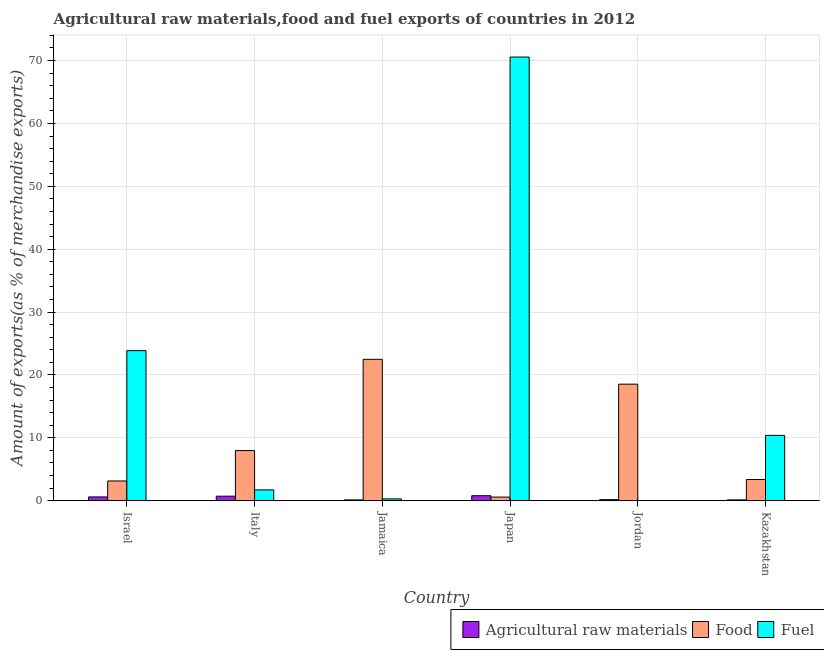How many groups of bars are there?
Provide a succinct answer. 6. Are the number of bars on each tick of the X-axis equal?
Keep it short and to the point. Yes. How many bars are there on the 3rd tick from the left?
Give a very brief answer. 3. How many bars are there on the 2nd tick from the right?
Your answer should be very brief. 3. What is the label of the 5th group of bars from the left?
Your answer should be very brief. Jordan. In how many cases, is the number of bars for a given country not equal to the number of legend labels?
Offer a very short reply. 0. What is the percentage of raw materials exports in Kazakhstan?
Give a very brief answer. 0.13. Across all countries, what is the maximum percentage of food exports?
Your answer should be very brief. 22.49. Across all countries, what is the minimum percentage of fuel exports?
Keep it short and to the point. 0. In which country was the percentage of food exports maximum?
Make the answer very short. Jamaica. In which country was the percentage of fuel exports minimum?
Your answer should be very brief. Jordan. What is the total percentage of food exports in the graph?
Offer a terse response. 56.09. What is the difference between the percentage of raw materials exports in Israel and that in Italy?
Your answer should be compact. -0.12. What is the difference between the percentage of food exports in Italy and the percentage of fuel exports in Kazakhstan?
Offer a terse response. -2.42. What is the average percentage of fuel exports per country?
Offer a terse response. 17.8. What is the difference between the percentage of raw materials exports and percentage of fuel exports in Jordan?
Give a very brief answer. 0.16. What is the ratio of the percentage of food exports in Israel to that in Jamaica?
Provide a succinct answer. 0.14. Is the percentage of raw materials exports in Italy less than that in Jamaica?
Ensure brevity in your answer.  No. Is the difference between the percentage of food exports in Jamaica and Kazakhstan greater than the difference between the percentage of raw materials exports in Jamaica and Kazakhstan?
Provide a succinct answer. Yes. What is the difference between the highest and the second highest percentage of raw materials exports?
Offer a terse response. 0.07. What is the difference between the highest and the lowest percentage of fuel exports?
Provide a succinct answer. 70.56. What does the 3rd bar from the left in Italy represents?
Give a very brief answer. Fuel. What does the 1st bar from the right in Kazakhstan represents?
Give a very brief answer. Fuel. Is it the case that in every country, the sum of the percentage of raw materials exports and percentage of food exports is greater than the percentage of fuel exports?
Your answer should be very brief. No. Are all the bars in the graph horizontal?
Provide a short and direct response. No. How many countries are there in the graph?
Provide a succinct answer. 6. Are the values on the major ticks of Y-axis written in scientific E-notation?
Make the answer very short. No. Does the graph contain grids?
Provide a short and direct response. Yes. Where does the legend appear in the graph?
Your answer should be very brief. Bottom right. How are the legend labels stacked?
Your answer should be compact. Horizontal. What is the title of the graph?
Your answer should be very brief. Agricultural raw materials,food and fuel exports of countries in 2012. What is the label or title of the Y-axis?
Your response must be concise. Amount of exports(as % of merchandise exports). What is the Amount of exports(as % of merchandise exports) of Agricultural raw materials in Israel?
Offer a terse response. 0.6. What is the Amount of exports(as % of merchandise exports) of Food in Israel?
Give a very brief answer. 3.14. What is the Amount of exports(as % of merchandise exports) of Fuel in Israel?
Offer a very short reply. 23.87. What is the Amount of exports(as % of merchandise exports) in Agricultural raw materials in Italy?
Your response must be concise. 0.72. What is the Amount of exports(as % of merchandise exports) in Food in Italy?
Your answer should be very brief. 7.97. What is the Amount of exports(as % of merchandise exports) of Fuel in Italy?
Your answer should be very brief. 1.72. What is the Amount of exports(as % of merchandise exports) of Agricultural raw materials in Jamaica?
Provide a succinct answer. 0.13. What is the Amount of exports(as % of merchandise exports) in Food in Jamaica?
Your answer should be very brief. 22.49. What is the Amount of exports(as % of merchandise exports) in Fuel in Jamaica?
Offer a terse response. 0.29. What is the Amount of exports(as % of merchandise exports) in Agricultural raw materials in Japan?
Provide a short and direct response. 0.8. What is the Amount of exports(as % of merchandise exports) in Food in Japan?
Offer a very short reply. 0.58. What is the Amount of exports(as % of merchandise exports) in Fuel in Japan?
Offer a terse response. 70.56. What is the Amount of exports(as % of merchandise exports) of Agricultural raw materials in Jordan?
Your answer should be very brief. 0.16. What is the Amount of exports(as % of merchandise exports) in Food in Jordan?
Provide a succinct answer. 18.54. What is the Amount of exports(as % of merchandise exports) of Fuel in Jordan?
Provide a short and direct response. 0. What is the Amount of exports(as % of merchandise exports) of Agricultural raw materials in Kazakhstan?
Provide a short and direct response. 0.13. What is the Amount of exports(as % of merchandise exports) of Food in Kazakhstan?
Ensure brevity in your answer.  3.38. What is the Amount of exports(as % of merchandise exports) of Fuel in Kazakhstan?
Provide a succinct answer. 10.39. Across all countries, what is the maximum Amount of exports(as % of merchandise exports) in Agricultural raw materials?
Ensure brevity in your answer.  0.8. Across all countries, what is the maximum Amount of exports(as % of merchandise exports) of Food?
Your answer should be compact. 22.49. Across all countries, what is the maximum Amount of exports(as % of merchandise exports) of Fuel?
Keep it short and to the point. 70.56. Across all countries, what is the minimum Amount of exports(as % of merchandise exports) in Agricultural raw materials?
Ensure brevity in your answer.  0.13. Across all countries, what is the minimum Amount of exports(as % of merchandise exports) in Food?
Keep it short and to the point. 0.58. Across all countries, what is the minimum Amount of exports(as % of merchandise exports) of Fuel?
Make the answer very short. 0. What is the total Amount of exports(as % of merchandise exports) in Agricultural raw materials in the graph?
Offer a terse response. 2.54. What is the total Amount of exports(as % of merchandise exports) of Food in the graph?
Your answer should be compact. 56.09. What is the total Amount of exports(as % of merchandise exports) of Fuel in the graph?
Ensure brevity in your answer.  106.82. What is the difference between the Amount of exports(as % of merchandise exports) in Agricultural raw materials in Israel and that in Italy?
Your response must be concise. -0.12. What is the difference between the Amount of exports(as % of merchandise exports) in Food in Israel and that in Italy?
Offer a terse response. -4.83. What is the difference between the Amount of exports(as % of merchandise exports) of Fuel in Israel and that in Italy?
Your answer should be very brief. 22.15. What is the difference between the Amount of exports(as % of merchandise exports) in Agricultural raw materials in Israel and that in Jamaica?
Your answer should be compact. 0.47. What is the difference between the Amount of exports(as % of merchandise exports) of Food in Israel and that in Jamaica?
Provide a succinct answer. -19.35. What is the difference between the Amount of exports(as % of merchandise exports) of Fuel in Israel and that in Jamaica?
Ensure brevity in your answer.  23.58. What is the difference between the Amount of exports(as % of merchandise exports) in Agricultural raw materials in Israel and that in Japan?
Keep it short and to the point. -0.19. What is the difference between the Amount of exports(as % of merchandise exports) of Food in Israel and that in Japan?
Provide a succinct answer. 2.56. What is the difference between the Amount of exports(as % of merchandise exports) in Fuel in Israel and that in Japan?
Offer a terse response. -46.69. What is the difference between the Amount of exports(as % of merchandise exports) of Agricultural raw materials in Israel and that in Jordan?
Keep it short and to the point. 0.44. What is the difference between the Amount of exports(as % of merchandise exports) in Food in Israel and that in Jordan?
Provide a succinct answer. -15.4. What is the difference between the Amount of exports(as % of merchandise exports) of Fuel in Israel and that in Jordan?
Make the answer very short. 23.87. What is the difference between the Amount of exports(as % of merchandise exports) of Agricultural raw materials in Israel and that in Kazakhstan?
Provide a succinct answer. 0.47. What is the difference between the Amount of exports(as % of merchandise exports) of Food in Israel and that in Kazakhstan?
Ensure brevity in your answer.  -0.24. What is the difference between the Amount of exports(as % of merchandise exports) of Fuel in Israel and that in Kazakhstan?
Your response must be concise. 13.47. What is the difference between the Amount of exports(as % of merchandise exports) in Agricultural raw materials in Italy and that in Jamaica?
Ensure brevity in your answer.  0.59. What is the difference between the Amount of exports(as % of merchandise exports) of Food in Italy and that in Jamaica?
Offer a very short reply. -14.51. What is the difference between the Amount of exports(as % of merchandise exports) in Fuel in Italy and that in Jamaica?
Provide a short and direct response. 1.43. What is the difference between the Amount of exports(as % of merchandise exports) in Agricultural raw materials in Italy and that in Japan?
Ensure brevity in your answer.  -0.07. What is the difference between the Amount of exports(as % of merchandise exports) of Food in Italy and that in Japan?
Keep it short and to the point. 7.39. What is the difference between the Amount of exports(as % of merchandise exports) in Fuel in Italy and that in Japan?
Offer a very short reply. -68.84. What is the difference between the Amount of exports(as % of merchandise exports) in Agricultural raw materials in Italy and that in Jordan?
Make the answer very short. 0.56. What is the difference between the Amount of exports(as % of merchandise exports) of Food in Italy and that in Jordan?
Provide a succinct answer. -10.56. What is the difference between the Amount of exports(as % of merchandise exports) in Fuel in Italy and that in Jordan?
Provide a succinct answer. 1.72. What is the difference between the Amount of exports(as % of merchandise exports) of Agricultural raw materials in Italy and that in Kazakhstan?
Your answer should be compact. 0.59. What is the difference between the Amount of exports(as % of merchandise exports) of Food in Italy and that in Kazakhstan?
Keep it short and to the point. 4.59. What is the difference between the Amount of exports(as % of merchandise exports) in Fuel in Italy and that in Kazakhstan?
Offer a very short reply. -8.67. What is the difference between the Amount of exports(as % of merchandise exports) of Agricultural raw materials in Jamaica and that in Japan?
Your answer should be compact. -0.67. What is the difference between the Amount of exports(as % of merchandise exports) of Food in Jamaica and that in Japan?
Give a very brief answer. 21.91. What is the difference between the Amount of exports(as % of merchandise exports) in Fuel in Jamaica and that in Japan?
Ensure brevity in your answer.  -70.27. What is the difference between the Amount of exports(as % of merchandise exports) of Agricultural raw materials in Jamaica and that in Jordan?
Make the answer very short. -0.04. What is the difference between the Amount of exports(as % of merchandise exports) of Food in Jamaica and that in Jordan?
Keep it short and to the point. 3.95. What is the difference between the Amount of exports(as % of merchandise exports) of Fuel in Jamaica and that in Jordan?
Your answer should be compact. 0.29. What is the difference between the Amount of exports(as % of merchandise exports) in Agricultural raw materials in Jamaica and that in Kazakhstan?
Your response must be concise. -0. What is the difference between the Amount of exports(as % of merchandise exports) of Food in Jamaica and that in Kazakhstan?
Keep it short and to the point. 19.11. What is the difference between the Amount of exports(as % of merchandise exports) in Fuel in Jamaica and that in Kazakhstan?
Provide a short and direct response. -10.1. What is the difference between the Amount of exports(as % of merchandise exports) of Agricultural raw materials in Japan and that in Jordan?
Offer a terse response. 0.63. What is the difference between the Amount of exports(as % of merchandise exports) of Food in Japan and that in Jordan?
Keep it short and to the point. -17.96. What is the difference between the Amount of exports(as % of merchandise exports) in Fuel in Japan and that in Jordan?
Provide a short and direct response. 70.56. What is the difference between the Amount of exports(as % of merchandise exports) of Agricultural raw materials in Japan and that in Kazakhstan?
Ensure brevity in your answer.  0.66. What is the difference between the Amount of exports(as % of merchandise exports) in Food in Japan and that in Kazakhstan?
Provide a short and direct response. -2.8. What is the difference between the Amount of exports(as % of merchandise exports) in Fuel in Japan and that in Kazakhstan?
Make the answer very short. 60.17. What is the difference between the Amount of exports(as % of merchandise exports) of Agricultural raw materials in Jordan and that in Kazakhstan?
Give a very brief answer. 0.03. What is the difference between the Amount of exports(as % of merchandise exports) of Food in Jordan and that in Kazakhstan?
Your response must be concise. 15.16. What is the difference between the Amount of exports(as % of merchandise exports) of Fuel in Jordan and that in Kazakhstan?
Give a very brief answer. -10.39. What is the difference between the Amount of exports(as % of merchandise exports) in Agricultural raw materials in Israel and the Amount of exports(as % of merchandise exports) in Food in Italy?
Provide a short and direct response. -7.37. What is the difference between the Amount of exports(as % of merchandise exports) in Agricultural raw materials in Israel and the Amount of exports(as % of merchandise exports) in Fuel in Italy?
Ensure brevity in your answer.  -1.11. What is the difference between the Amount of exports(as % of merchandise exports) in Food in Israel and the Amount of exports(as % of merchandise exports) in Fuel in Italy?
Ensure brevity in your answer.  1.42. What is the difference between the Amount of exports(as % of merchandise exports) in Agricultural raw materials in Israel and the Amount of exports(as % of merchandise exports) in Food in Jamaica?
Provide a succinct answer. -21.88. What is the difference between the Amount of exports(as % of merchandise exports) of Agricultural raw materials in Israel and the Amount of exports(as % of merchandise exports) of Fuel in Jamaica?
Your answer should be very brief. 0.32. What is the difference between the Amount of exports(as % of merchandise exports) in Food in Israel and the Amount of exports(as % of merchandise exports) in Fuel in Jamaica?
Give a very brief answer. 2.85. What is the difference between the Amount of exports(as % of merchandise exports) in Agricultural raw materials in Israel and the Amount of exports(as % of merchandise exports) in Food in Japan?
Offer a very short reply. 0.02. What is the difference between the Amount of exports(as % of merchandise exports) of Agricultural raw materials in Israel and the Amount of exports(as % of merchandise exports) of Fuel in Japan?
Give a very brief answer. -69.96. What is the difference between the Amount of exports(as % of merchandise exports) in Food in Israel and the Amount of exports(as % of merchandise exports) in Fuel in Japan?
Provide a short and direct response. -67.42. What is the difference between the Amount of exports(as % of merchandise exports) of Agricultural raw materials in Israel and the Amount of exports(as % of merchandise exports) of Food in Jordan?
Your answer should be compact. -17.93. What is the difference between the Amount of exports(as % of merchandise exports) in Agricultural raw materials in Israel and the Amount of exports(as % of merchandise exports) in Fuel in Jordan?
Ensure brevity in your answer.  0.6. What is the difference between the Amount of exports(as % of merchandise exports) of Food in Israel and the Amount of exports(as % of merchandise exports) of Fuel in Jordan?
Keep it short and to the point. 3.14. What is the difference between the Amount of exports(as % of merchandise exports) of Agricultural raw materials in Israel and the Amount of exports(as % of merchandise exports) of Food in Kazakhstan?
Provide a short and direct response. -2.77. What is the difference between the Amount of exports(as % of merchandise exports) of Agricultural raw materials in Israel and the Amount of exports(as % of merchandise exports) of Fuel in Kazakhstan?
Keep it short and to the point. -9.79. What is the difference between the Amount of exports(as % of merchandise exports) of Food in Israel and the Amount of exports(as % of merchandise exports) of Fuel in Kazakhstan?
Your response must be concise. -7.25. What is the difference between the Amount of exports(as % of merchandise exports) in Agricultural raw materials in Italy and the Amount of exports(as % of merchandise exports) in Food in Jamaica?
Offer a terse response. -21.77. What is the difference between the Amount of exports(as % of merchandise exports) of Agricultural raw materials in Italy and the Amount of exports(as % of merchandise exports) of Fuel in Jamaica?
Your response must be concise. 0.43. What is the difference between the Amount of exports(as % of merchandise exports) of Food in Italy and the Amount of exports(as % of merchandise exports) of Fuel in Jamaica?
Your answer should be very brief. 7.68. What is the difference between the Amount of exports(as % of merchandise exports) of Agricultural raw materials in Italy and the Amount of exports(as % of merchandise exports) of Food in Japan?
Keep it short and to the point. 0.14. What is the difference between the Amount of exports(as % of merchandise exports) of Agricultural raw materials in Italy and the Amount of exports(as % of merchandise exports) of Fuel in Japan?
Provide a short and direct response. -69.84. What is the difference between the Amount of exports(as % of merchandise exports) in Food in Italy and the Amount of exports(as % of merchandise exports) in Fuel in Japan?
Your response must be concise. -62.59. What is the difference between the Amount of exports(as % of merchandise exports) in Agricultural raw materials in Italy and the Amount of exports(as % of merchandise exports) in Food in Jordan?
Offer a terse response. -17.82. What is the difference between the Amount of exports(as % of merchandise exports) of Agricultural raw materials in Italy and the Amount of exports(as % of merchandise exports) of Fuel in Jordan?
Offer a very short reply. 0.72. What is the difference between the Amount of exports(as % of merchandise exports) in Food in Italy and the Amount of exports(as % of merchandise exports) in Fuel in Jordan?
Ensure brevity in your answer.  7.97. What is the difference between the Amount of exports(as % of merchandise exports) of Agricultural raw materials in Italy and the Amount of exports(as % of merchandise exports) of Food in Kazakhstan?
Your answer should be very brief. -2.66. What is the difference between the Amount of exports(as % of merchandise exports) of Agricultural raw materials in Italy and the Amount of exports(as % of merchandise exports) of Fuel in Kazakhstan?
Provide a succinct answer. -9.67. What is the difference between the Amount of exports(as % of merchandise exports) in Food in Italy and the Amount of exports(as % of merchandise exports) in Fuel in Kazakhstan?
Your answer should be very brief. -2.42. What is the difference between the Amount of exports(as % of merchandise exports) of Agricultural raw materials in Jamaica and the Amount of exports(as % of merchandise exports) of Food in Japan?
Provide a short and direct response. -0.45. What is the difference between the Amount of exports(as % of merchandise exports) in Agricultural raw materials in Jamaica and the Amount of exports(as % of merchandise exports) in Fuel in Japan?
Offer a very short reply. -70.43. What is the difference between the Amount of exports(as % of merchandise exports) in Food in Jamaica and the Amount of exports(as % of merchandise exports) in Fuel in Japan?
Offer a terse response. -48.07. What is the difference between the Amount of exports(as % of merchandise exports) of Agricultural raw materials in Jamaica and the Amount of exports(as % of merchandise exports) of Food in Jordan?
Make the answer very short. -18.41. What is the difference between the Amount of exports(as % of merchandise exports) in Agricultural raw materials in Jamaica and the Amount of exports(as % of merchandise exports) in Fuel in Jordan?
Ensure brevity in your answer.  0.13. What is the difference between the Amount of exports(as % of merchandise exports) in Food in Jamaica and the Amount of exports(as % of merchandise exports) in Fuel in Jordan?
Give a very brief answer. 22.49. What is the difference between the Amount of exports(as % of merchandise exports) of Agricultural raw materials in Jamaica and the Amount of exports(as % of merchandise exports) of Food in Kazakhstan?
Offer a terse response. -3.25. What is the difference between the Amount of exports(as % of merchandise exports) in Agricultural raw materials in Jamaica and the Amount of exports(as % of merchandise exports) in Fuel in Kazakhstan?
Your answer should be very brief. -10.26. What is the difference between the Amount of exports(as % of merchandise exports) in Food in Jamaica and the Amount of exports(as % of merchandise exports) in Fuel in Kazakhstan?
Make the answer very short. 12.1. What is the difference between the Amount of exports(as % of merchandise exports) in Agricultural raw materials in Japan and the Amount of exports(as % of merchandise exports) in Food in Jordan?
Your answer should be very brief. -17.74. What is the difference between the Amount of exports(as % of merchandise exports) in Agricultural raw materials in Japan and the Amount of exports(as % of merchandise exports) in Fuel in Jordan?
Offer a terse response. 0.8. What is the difference between the Amount of exports(as % of merchandise exports) in Food in Japan and the Amount of exports(as % of merchandise exports) in Fuel in Jordan?
Your answer should be very brief. 0.58. What is the difference between the Amount of exports(as % of merchandise exports) of Agricultural raw materials in Japan and the Amount of exports(as % of merchandise exports) of Food in Kazakhstan?
Make the answer very short. -2.58. What is the difference between the Amount of exports(as % of merchandise exports) of Agricultural raw materials in Japan and the Amount of exports(as % of merchandise exports) of Fuel in Kazakhstan?
Give a very brief answer. -9.59. What is the difference between the Amount of exports(as % of merchandise exports) of Food in Japan and the Amount of exports(as % of merchandise exports) of Fuel in Kazakhstan?
Your answer should be very brief. -9.81. What is the difference between the Amount of exports(as % of merchandise exports) of Agricultural raw materials in Jordan and the Amount of exports(as % of merchandise exports) of Food in Kazakhstan?
Give a very brief answer. -3.21. What is the difference between the Amount of exports(as % of merchandise exports) in Agricultural raw materials in Jordan and the Amount of exports(as % of merchandise exports) in Fuel in Kazakhstan?
Your response must be concise. -10.23. What is the difference between the Amount of exports(as % of merchandise exports) of Food in Jordan and the Amount of exports(as % of merchandise exports) of Fuel in Kazakhstan?
Give a very brief answer. 8.15. What is the average Amount of exports(as % of merchandise exports) in Agricultural raw materials per country?
Give a very brief answer. 0.42. What is the average Amount of exports(as % of merchandise exports) of Food per country?
Offer a terse response. 9.35. What is the average Amount of exports(as % of merchandise exports) of Fuel per country?
Provide a short and direct response. 17.8. What is the difference between the Amount of exports(as % of merchandise exports) of Agricultural raw materials and Amount of exports(as % of merchandise exports) of Food in Israel?
Keep it short and to the point. -2.54. What is the difference between the Amount of exports(as % of merchandise exports) of Agricultural raw materials and Amount of exports(as % of merchandise exports) of Fuel in Israel?
Make the answer very short. -23.26. What is the difference between the Amount of exports(as % of merchandise exports) of Food and Amount of exports(as % of merchandise exports) of Fuel in Israel?
Give a very brief answer. -20.72. What is the difference between the Amount of exports(as % of merchandise exports) of Agricultural raw materials and Amount of exports(as % of merchandise exports) of Food in Italy?
Provide a succinct answer. -7.25. What is the difference between the Amount of exports(as % of merchandise exports) of Agricultural raw materials and Amount of exports(as % of merchandise exports) of Fuel in Italy?
Give a very brief answer. -1. What is the difference between the Amount of exports(as % of merchandise exports) in Food and Amount of exports(as % of merchandise exports) in Fuel in Italy?
Make the answer very short. 6.25. What is the difference between the Amount of exports(as % of merchandise exports) of Agricultural raw materials and Amount of exports(as % of merchandise exports) of Food in Jamaica?
Keep it short and to the point. -22.36. What is the difference between the Amount of exports(as % of merchandise exports) of Agricultural raw materials and Amount of exports(as % of merchandise exports) of Fuel in Jamaica?
Offer a very short reply. -0.16. What is the difference between the Amount of exports(as % of merchandise exports) of Food and Amount of exports(as % of merchandise exports) of Fuel in Jamaica?
Provide a short and direct response. 22.2. What is the difference between the Amount of exports(as % of merchandise exports) of Agricultural raw materials and Amount of exports(as % of merchandise exports) of Food in Japan?
Offer a terse response. 0.22. What is the difference between the Amount of exports(as % of merchandise exports) in Agricultural raw materials and Amount of exports(as % of merchandise exports) in Fuel in Japan?
Offer a terse response. -69.76. What is the difference between the Amount of exports(as % of merchandise exports) in Food and Amount of exports(as % of merchandise exports) in Fuel in Japan?
Make the answer very short. -69.98. What is the difference between the Amount of exports(as % of merchandise exports) of Agricultural raw materials and Amount of exports(as % of merchandise exports) of Food in Jordan?
Offer a very short reply. -18.37. What is the difference between the Amount of exports(as % of merchandise exports) in Agricultural raw materials and Amount of exports(as % of merchandise exports) in Fuel in Jordan?
Your answer should be compact. 0.16. What is the difference between the Amount of exports(as % of merchandise exports) in Food and Amount of exports(as % of merchandise exports) in Fuel in Jordan?
Provide a succinct answer. 18.54. What is the difference between the Amount of exports(as % of merchandise exports) of Agricultural raw materials and Amount of exports(as % of merchandise exports) of Food in Kazakhstan?
Your answer should be compact. -3.25. What is the difference between the Amount of exports(as % of merchandise exports) of Agricultural raw materials and Amount of exports(as % of merchandise exports) of Fuel in Kazakhstan?
Offer a very short reply. -10.26. What is the difference between the Amount of exports(as % of merchandise exports) in Food and Amount of exports(as % of merchandise exports) in Fuel in Kazakhstan?
Your response must be concise. -7.01. What is the ratio of the Amount of exports(as % of merchandise exports) in Agricultural raw materials in Israel to that in Italy?
Make the answer very short. 0.84. What is the ratio of the Amount of exports(as % of merchandise exports) of Food in Israel to that in Italy?
Give a very brief answer. 0.39. What is the ratio of the Amount of exports(as % of merchandise exports) of Fuel in Israel to that in Italy?
Offer a very short reply. 13.89. What is the ratio of the Amount of exports(as % of merchandise exports) of Agricultural raw materials in Israel to that in Jamaica?
Provide a succinct answer. 4.68. What is the ratio of the Amount of exports(as % of merchandise exports) in Food in Israel to that in Jamaica?
Offer a terse response. 0.14. What is the ratio of the Amount of exports(as % of merchandise exports) in Fuel in Israel to that in Jamaica?
Your answer should be very brief. 82.84. What is the ratio of the Amount of exports(as % of merchandise exports) in Agricultural raw materials in Israel to that in Japan?
Provide a succinct answer. 0.76. What is the ratio of the Amount of exports(as % of merchandise exports) of Food in Israel to that in Japan?
Offer a very short reply. 5.43. What is the ratio of the Amount of exports(as % of merchandise exports) of Fuel in Israel to that in Japan?
Make the answer very short. 0.34. What is the ratio of the Amount of exports(as % of merchandise exports) of Agricultural raw materials in Israel to that in Jordan?
Your answer should be very brief. 3.67. What is the ratio of the Amount of exports(as % of merchandise exports) of Food in Israel to that in Jordan?
Your response must be concise. 0.17. What is the ratio of the Amount of exports(as % of merchandise exports) of Fuel in Israel to that in Jordan?
Make the answer very short. 1.39e+05. What is the ratio of the Amount of exports(as % of merchandise exports) in Agricultural raw materials in Israel to that in Kazakhstan?
Offer a terse response. 4.59. What is the ratio of the Amount of exports(as % of merchandise exports) in Fuel in Israel to that in Kazakhstan?
Your answer should be compact. 2.3. What is the ratio of the Amount of exports(as % of merchandise exports) in Agricultural raw materials in Italy to that in Jamaica?
Offer a terse response. 5.59. What is the ratio of the Amount of exports(as % of merchandise exports) in Food in Italy to that in Jamaica?
Ensure brevity in your answer.  0.35. What is the ratio of the Amount of exports(as % of merchandise exports) in Fuel in Italy to that in Jamaica?
Offer a very short reply. 5.96. What is the ratio of the Amount of exports(as % of merchandise exports) of Agricultural raw materials in Italy to that in Japan?
Provide a short and direct response. 0.91. What is the ratio of the Amount of exports(as % of merchandise exports) in Food in Italy to that in Japan?
Ensure brevity in your answer.  13.77. What is the ratio of the Amount of exports(as % of merchandise exports) of Fuel in Italy to that in Japan?
Keep it short and to the point. 0.02. What is the ratio of the Amount of exports(as % of merchandise exports) of Agricultural raw materials in Italy to that in Jordan?
Your answer should be compact. 4.39. What is the ratio of the Amount of exports(as % of merchandise exports) of Food in Italy to that in Jordan?
Your response must be concise. 0.43. What is the ratio of the Amount of exports(as % of merchandise exports) of Fuel in Italy to that in Jordan?
Offer a very short reply. 9990.01. What is the ratio of the Amount of exports(as % of merchandise exports) in Agricultural raw materials in Italy to that in Kazakhstan?
Your answer should be very brief. 5.49. What is the ratio of the Amount of exports(as % of merchandise exports) in Food in Italy to that in Kazakhstan?
Your answer should be compact. 2.36. What is the ratio of the Amount of exports(as % of merchandise exports) in Fuel in Italy to that in Kazakhstan?
Make the answer very short. 0.17. What is the ratio of the Amount of exports(as % of merchandise exports) in Agricultural raw materials in Jamaica to that in Japan?
Your answer should be very brief. 0.16. What is the ratio of the Amount of exports(as % of merchandise exports) of Food in Jamaica to that in Japan?
Your response must be concise. 38.84. What is the ratio of the Amount of exports(as % of merchandise exports) in Fuel in Jamaica to that in Japan?
Your answer should be compact. 0. What is the ratio of the Amount of exports(as % of merchandise exports) of Agricultural raw materials in Jamaica to that in Jordan?
Offer a terse response. 0.78. What is the ratio of the Amount of exports(as % of merchandise exports) in Food in Jamaica to that in Jordan?
Your response must be concise. 1.21. What is the ratio of the Amount of exports(as % of merchandise exports) of Fuel in Jamaica to that in Jordan?
Your response must be concise. 1675.32. What is the ratio of the Amount of exports(as % of merchandise exports) in Agricultural raw materials in Jamaica to that in Kazakhstan?
Ensure brevity in your answer.  0.98. What is the ratio of the Amount of exports(as % of merchandise exports) in Food in Jamaica to that in Kazakhstan?
Your answer should be compact. 6.66. What is the ratio of the Amount of exports(as % of merchandise exports) of Fuel in Jamaica to that in Kazakhstan?
Offer a terse response. 0.03. What is the ratio of the Amount of exports(as % of merchandise exports) in Agricultural raw materials in Japan to that in Jordan?
Your response must be concise. 4.84. What is the ratio of the Amount of exports(as % of merchandise exports) in Food in Japan to that in Jordan?
Keep it short and to the point. 0.03. What is the ratio of the Amount of exports(as % of merchandise exports) of Fuel in Japan to that in Jordan?
Provide a short and direct response. 4.10e+05. What is the ratio of the Amount of exports(as % of merchandise exports) of Agricultural raw materials in Japan to that in Kazakhstan?
Make the answer very short. 6.06. What is the ratio of the Amount of exports(as % of merchandise exports) in Food in Japan to that in Kazakhstan?
Keep it short and to the point. 0.17. What is the ratio of the Amount of exports(as % of merchandise exports) of Fuel in Japan to that in Kazakhstan?
Offer a terse response. 6.79. What is the ratio of the Amount of exports(as % of merchandise exports) of Agricultural raw materials in Jordan to that in Kazakhstan?
Keep it short and to the point. 1.25. What is the ratio of the Amount of exports(as % of merchandise exports) of Food in Jordan to that in Kazakhstan?
Your answer should be compact. 5.49. What is the ratio of the Amount of exports(as % of merchandise exports) of Fuel in Jordan to that in Kazakhstan?
Your answer should be compact. 0. What is the difference between the highest and the second highest Amount of exports(as % of merchandise exports) in Agricultural raw materials?
Make the answer very short. 0.07. What is the difference between the highest and the second highest Amount of exports(as % of merchandise exports) of Food?
Your response must be concise. 3.95. What is the difference between the highest and the second highest Amount of exports(as % of merchandise exports) in Fuel?
Give a very brief answer. 46.69. What is the difference between the highest and the lowest Amount of exports(as % of merchandise exports) in Food?
Keep it short and to the point. 21.91. What is the difference between the highest and the lowest Amount of exports(as % of merchandise exports) in Fuel?
Offer a terse response. 70.56. 